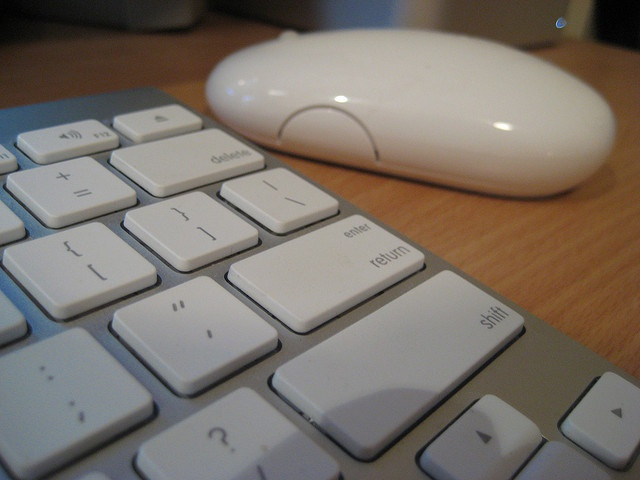Describe the objects in this image and their specific colors. I can see keyboard in black, darkgray, and gray tones and mouse in black, darkgray, and gray tones in this image. 